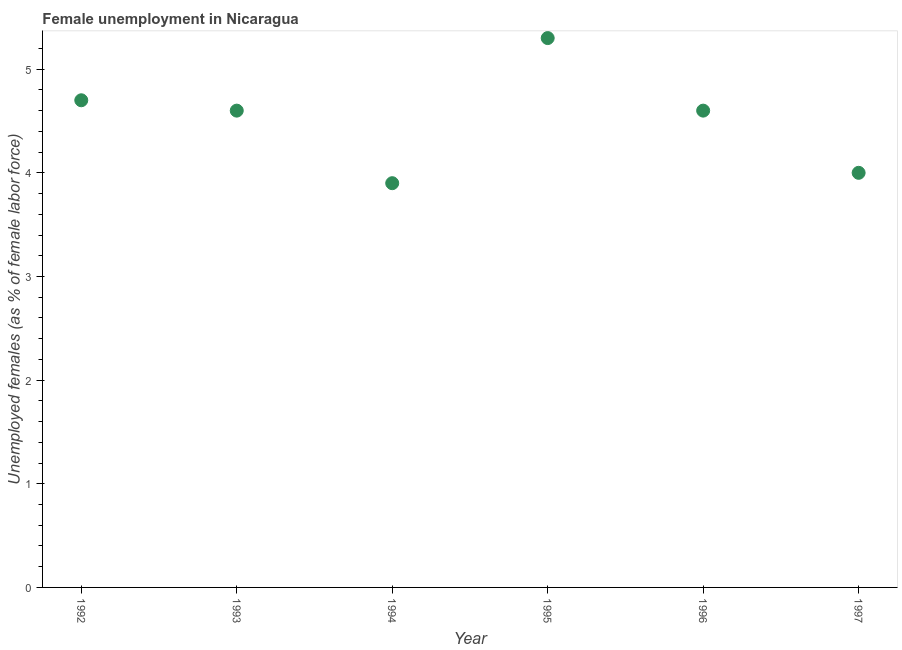What is the unemployed females population in 1993?
Your answer should be compact. 4.6. Across all years, what is the maximum unemployed females population?
Offer a terse response. 5.3. Across all years, what is the minimum unemployed females population?
Keep it short and to the point. 3.9. In which year was the unemployed females population maximum?
Your answer should be compact. 1995. What is the sum of the unemployed females population?
Ensure brevity in your answer.  27.1. What is the difference between the unemployed females population in 1992 and 1995?
Your answer should be very brief. -0.6. What is the average unemployed females population per year?
Offer a very short reply. 4.52. What is the median unemployed females population?
Offer a terse response. 4.6. In how many years, is the unemployed females population greater than 2.2 %?
Your answer should be compact. 6. What is the ratio of the unemployed females population in 1994 to that in 1997?
Your response must be concise. 0.98. What is the difference between the highest and the second highest unemployed females population?
Make the answer very short. 0.6. Is the sum of the unemployed females population in 1992 and 1997 greater than the maximum unemployed females population across all years?
Your answer should be very brief. Yes. What is the difference between the highest and the lowest unemployed females population?
Offer a terse response. 1.4. Does the unemployed females population monotonically increase over the years?
Give a very brief answer. No. What is the difference between two consecutive major ticks on the Y-axis?
Keep it short and to the point. 1. Are the values on the major ticks of Y-axis written in scientific E-notation?
Offer a very short reply. No. Does the graph contain grids?
Make the answer very short. No. What is the title of the graph?
Ensure brevity in your answer.  Female unemployment in Nicaragua. What is the label or title of the X-axis?
Provide a short and direct response. Year. What is the label or title of the Y-axis?
Give a very brief answer. Unemployed females (as % of female labor force). What is the Unemployed females (as % of female labor force) in 1992?
Ensure brevity in your answer.  4.7. What is the Unemployed females (as % of female labor force) in 1993?
Your response must be concise. 4.6. What is the Unemployed females (as % of female labor force) in 1994?
Ensure brevity in your answer.  3.9. What is the Unemployed females (as % of female labor force) in 1995?
Keep it short and to the point. 5.3. What is the Unemployed females (as % of female labor force) in 1996?
Your answer should be compact. 4.6. What is the difference between the Unemployed females (as % of female labor force) in 1992 and 1995?
Ensure brevity in your answer.  -0.6. What is the difference between the Unemployed females (as % of female labor force) in 1992 and 1996?
Your answer should be compact. 0.1. What is the difference between the Unemployed females (as % of female labor force) in 1993 and 1994?
Your response must be concise. 0.7. What is the difference between the Unemployed females (as % of female labor force) in 1993 and 1995?
Provide a succinct answer. -0.7. What is the difference between the Unemployed females (as % of female labor force) in 1993 and 1996?
Your answer should be very brief. 0. What is the difference between the Unemployed females (as % of female labor force) in 1993 and 1997?
Keep it short and to the point. 0.6. What is the difference between the Unemployed females (as % of female labor force) in 1994 and 1996?
Give a very brief answer. -0.7. What is the difference between the Unemployed females (as % of female labor force) in 1995 and 1997?
Your answer should be very brief. 1.3. What is the ratio of the Unemployed females (as % of female labor force) in 1992 to that in 1993?
Your answer should be compact. 1.02. What is the ratio of the Unemployed females (as % of female labor force) in 1992 to that in 1994?
Provide a short and direct response. 1.21. What is the ratio of the Unemployed females (as % of female labor force) in 1992 to that in 1995?
Keep it short and to the point. 0.89. What is the ratio of the Unemployed females (as % of female labor force) in 1992 to that in 1997?
Make the answer very short. 1.18. What is the ratio of the Unemployed females (as % of female labor force) in 1993 to that in 1994?
Keep it short and to the point. 1.18. What is the ratio of the Unemployed females (as % of female labor force) in 1993 to that in 1995?
Offer a terse response. 0.87. What is the ratio of the Unemployed females (as % of female labor force) in 1993 to that in 1996?
Offer a very short reply. 1. What is the ratio of the Unemployed females (as % of female labor force) in 1993 to that in 1997?
Keep it short and to the point. 1.15. What is the ratio of the Unemployed females (as % of female labor force) in 1994 to that in 1995?
Your answer should be very brief. 0.74. What is the ratio of the Unemployed females (as % of female labor force) in 1994 to that in 1996?
Provide a short and direct response. 0.85. What is the ratio of the Unemployed females (as % of female labor force) in 1995 to that in 1996?
Your response must be concise. 1.15. What is the ratio of the Unemployed females (as % of female labor force) in 1995 to that in 1997?
Provide a short and direct response. 1.32. What is the ratio of the Unemployed females (as % of female labor force) in 1996 to that in 1997?
Ensure brevity in your answer.  1.15. 